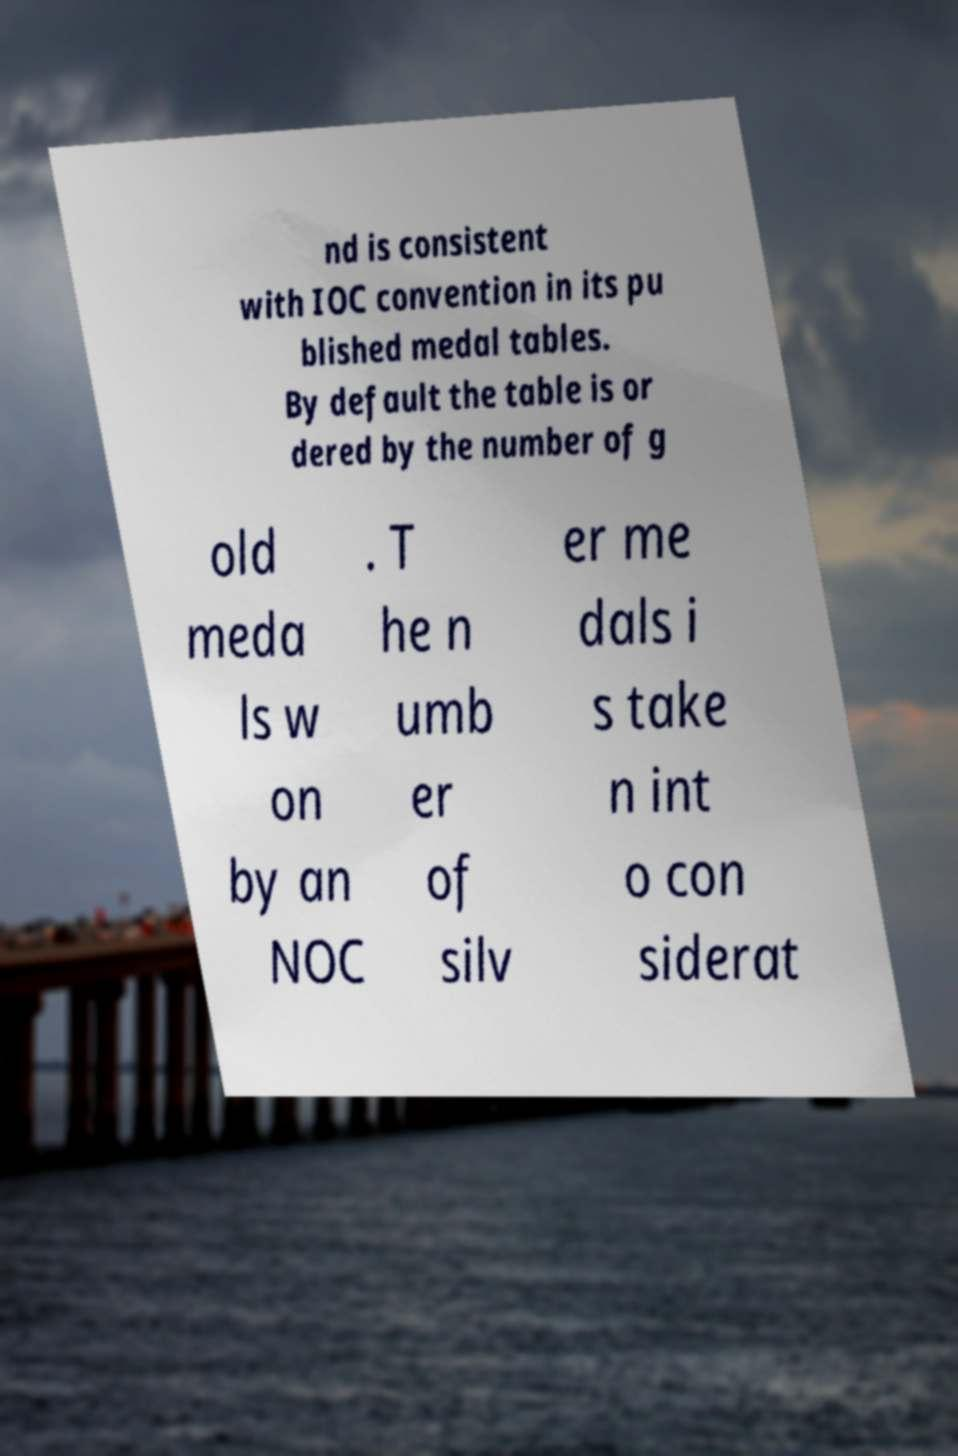I need the written content from this picture converted into text. Can you do that? nd is consistent with IOC convention in its pu blished medal tables. By default the table is or dered by the number of g old meda ls w on by an NOC . T he n umb er of silv er me dals i s take n int o con siderat 